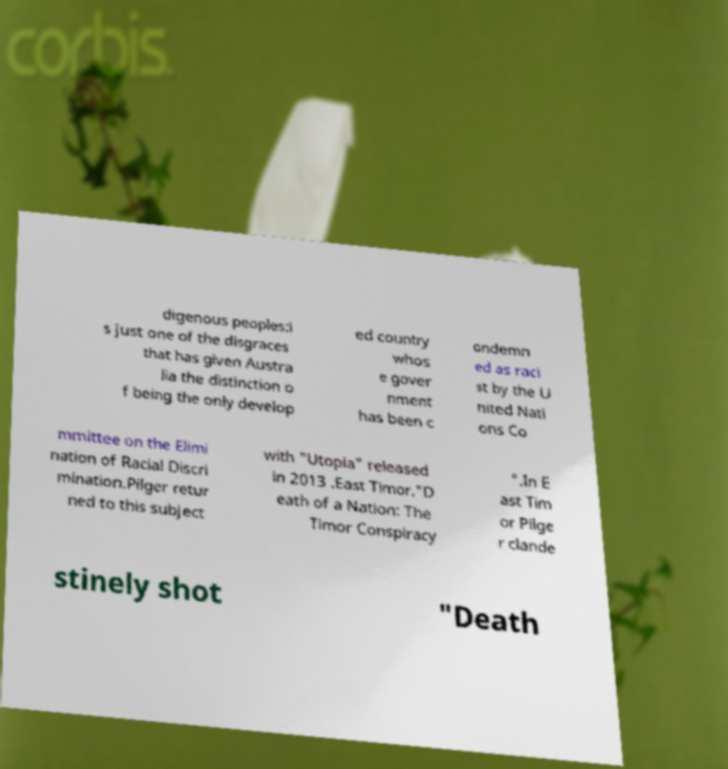What messages or text are displayed in this image? I need them in a readable, typed format. digenous peoples:i s just one of the disgraces that has given Austra lia the distinction o f being the only develop ed country whos e gover nment has been c ondemn ed as raci st by the U nited Nati ons Co mmittee on the Elimi nation of Racial Discri mination.Pilger retur ned to this subject with "Utopia" released in 2013 .East Timor."D eath of a Nation: The Timor Conspiracy ".In E ast Tim or Pilge r clande stinely shot "Death 